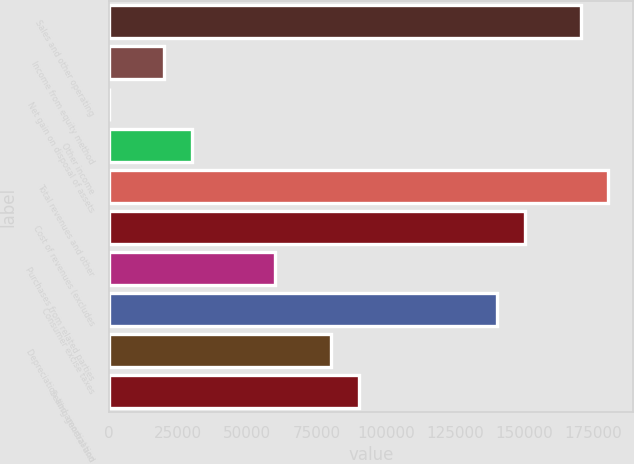Convert chart to OTSL. <chart><loc_0><loc_0><loc_500><loc_500><bar_chart><fcel>Sales and other operating<fcel>Income from equity method<fcel>Net gain on disposal of assets<fcel>Other income<fcel>Total revenues and other<fcel>Cost of revenues (excludes<fcel>Purchases from related parties<fcel>Consumer excise taxes<fcel>Depreciation and amortization<fcel>Selling general and<nl><fcel>170428<fcel>20055.6<fcel>6<fcel>30080.4<fcel>180452<fcel>150378<fcel>60154.8<fcel>140353<fcel>80204.4<fcel>90229.2<nl></chart> 